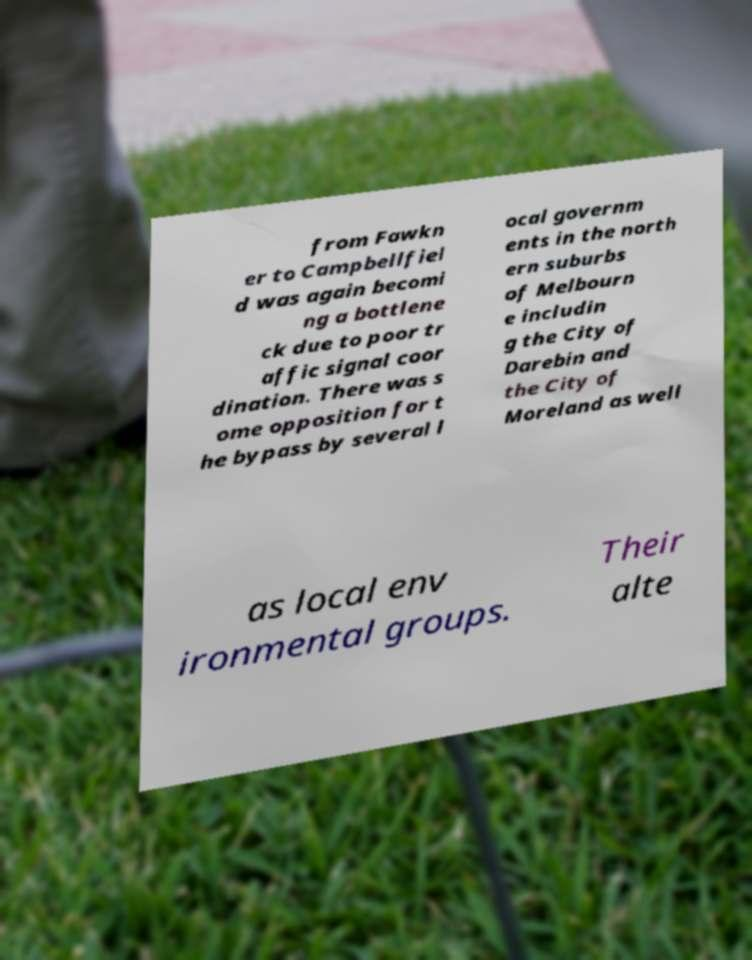Could you assist in decoding the text presented in this image and type it out clearly? from Fawkn er to Campbellfiel d was again becomi ng a bottlene ck due to poor tr affic signal coor dination. There was s ome opposition for t he bypass by several l ocal governm ents in the north ern suburbs of Melbourn e includin g the City of Darebin and the City of Moreland as well as local env ironmental groups. Their alte 